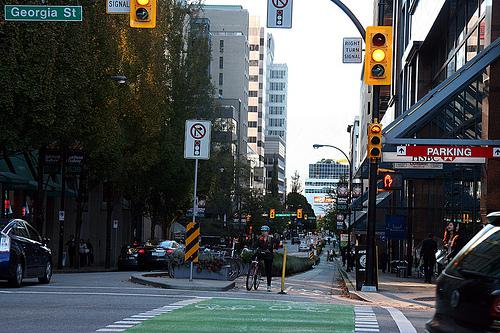Question: what color are the street lights?
Choices:
A. Red.
B. Green.
C. Yellow.
D. Blue.
Answer with the letter. Answer: C Question: where is this taken?
Choices:
A. A forest.
B. A city.
C. A mountain.
D. A beach.
Answer with the letter. Answer: B Question: what does the red sign say?
Choices:
A. Stop.
B. Warning.
C. No trespassing.
D. Parking.
Answer with the letter. Answer: D Question: what is in the background?
Choices:
A. Art.
B. Clouds.
C. Animals.
D. Buildings.
Answer with the letter. Answer: D 